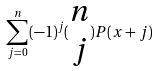Convert formula to latex. <formula><loc_0><loc_0><loc_500><loc_500>\sum _ { j = 0 } ^ { n } ( - 1 ) ^ { j } ( \begin{matrix} n \\ j \end{matrix} ) P ( x + j )</formula> 